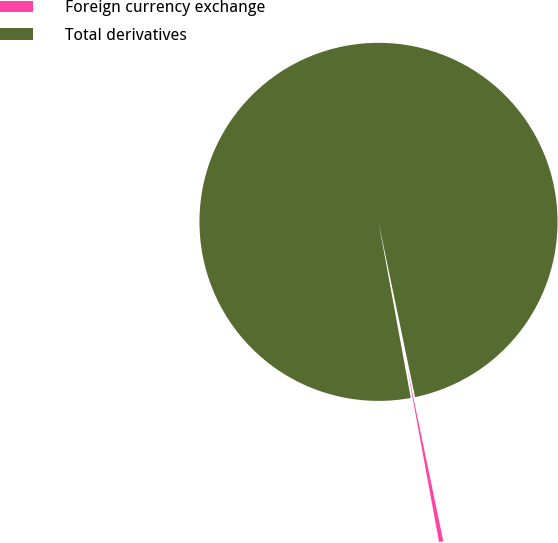<chart> <loc_0><loc_0><loc_500><loc_500><pie_chart><fcel>Foreign currency exchange<fcel>Total derivatives<nl><fcel>0.39%<fcel>99.61%<nl></chart> 